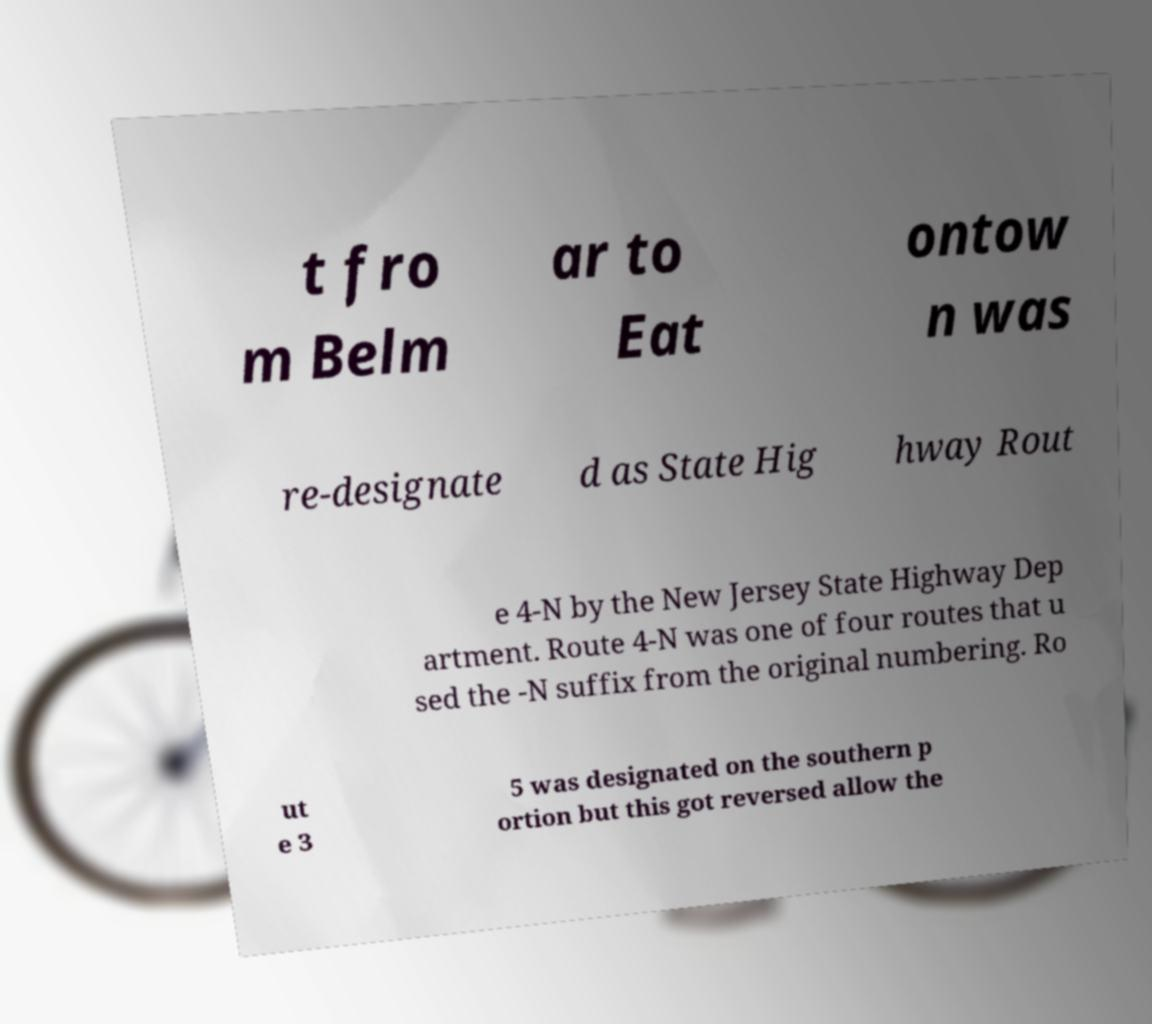I need the written content from this picture converted into text. Can you do that? t fro m Belm ar to Eat ontow n was re-designate d as State Hig hway Rout e 4-N by the New Jersey State Highway Dep artment. Route 4-N was one of four routes that u sed the -N suffix from the original numbering. Ro ut e 3 5 was designated on the southern p ortion but this got reversed allow the 